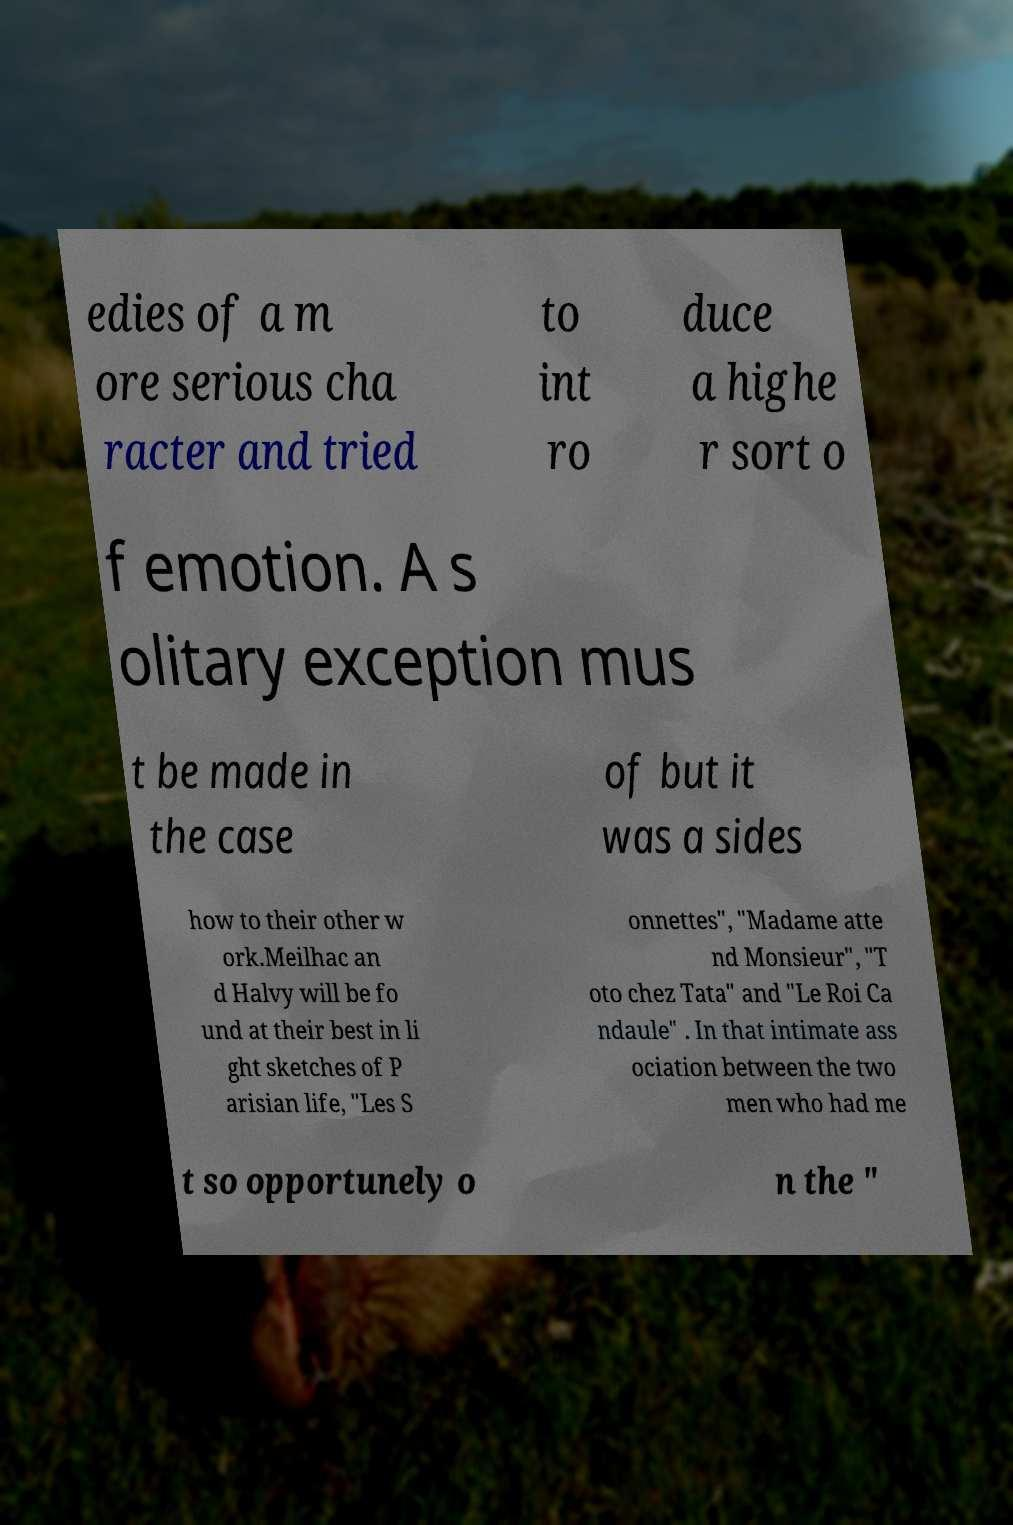Please identify and transcribe the text found in this image. edies of a m ore serious cha racter and tried to int ro duce a highe r sort o f emotion. A s olitary exception mus t be made in the case of but it was a sides how to their other w ork.Meilhac an d Halvy will be fo und at their best in li ght sketches of P arisian life, "Les S onnettes", "Madame atte nd Monsieur", "T oto chez Tata" and "Le Roi Ca ndaule" . In that intimate ass ociation between the two men who had me t so opportunely o n the " 